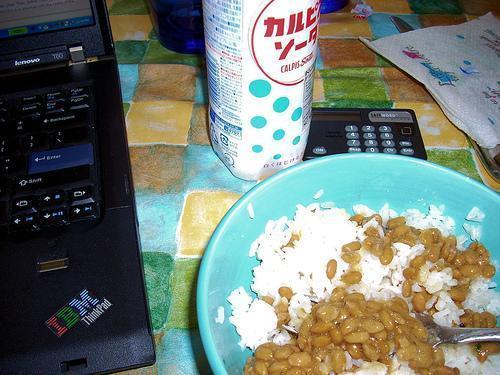How many remotes can be seen?
Give a very brief answer. 1. 